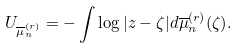Convert formula to latex. <formula><loc_0><loc_0><loc_500><loc_500>U _ { { \overline { \mu } } _ { n } ^ { ( r ) } } = - \int \log | z - \zeta | d { { \overline { \mu } } _ { n } ^ { ( r ) } ( \zeta ) } .</formula> 